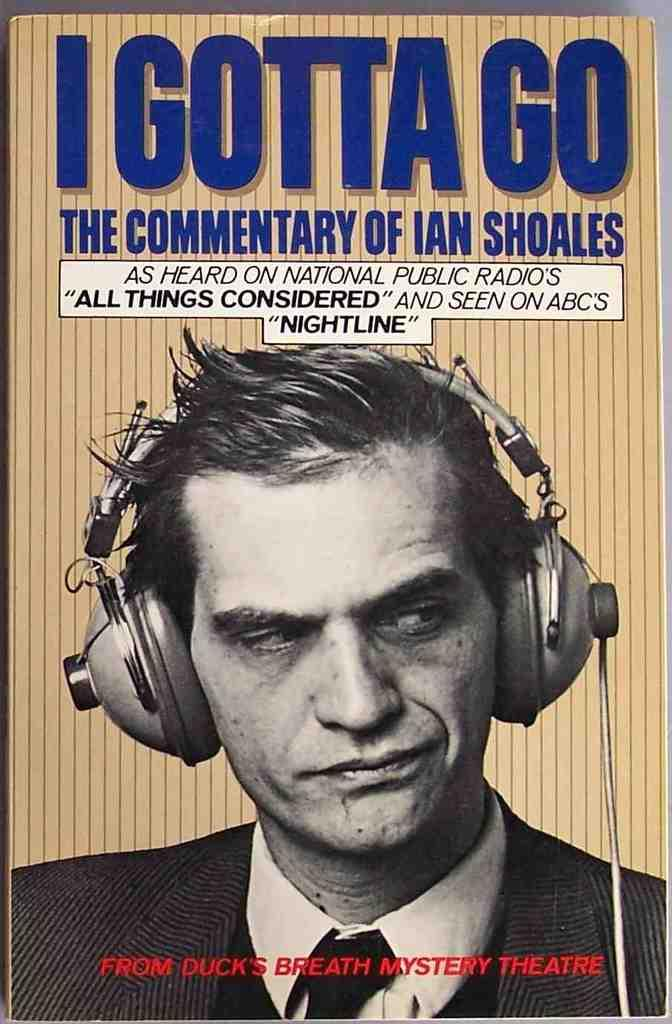What is depicted on the poster in the picture? The poster features a man wearing a suit and a tie. What is the man in the poster holding or wearing on his head? The man is wearing a headset. Is there any text visible in the image? Yes, there is text at the top of the image. What type of zipper can be seen on the man's suit in the image? There is no zipper visible on the man's suit in the image. How many stitches are present on the man's tie in the image? There is no information about the number of stitches on the man's tie in the image. 